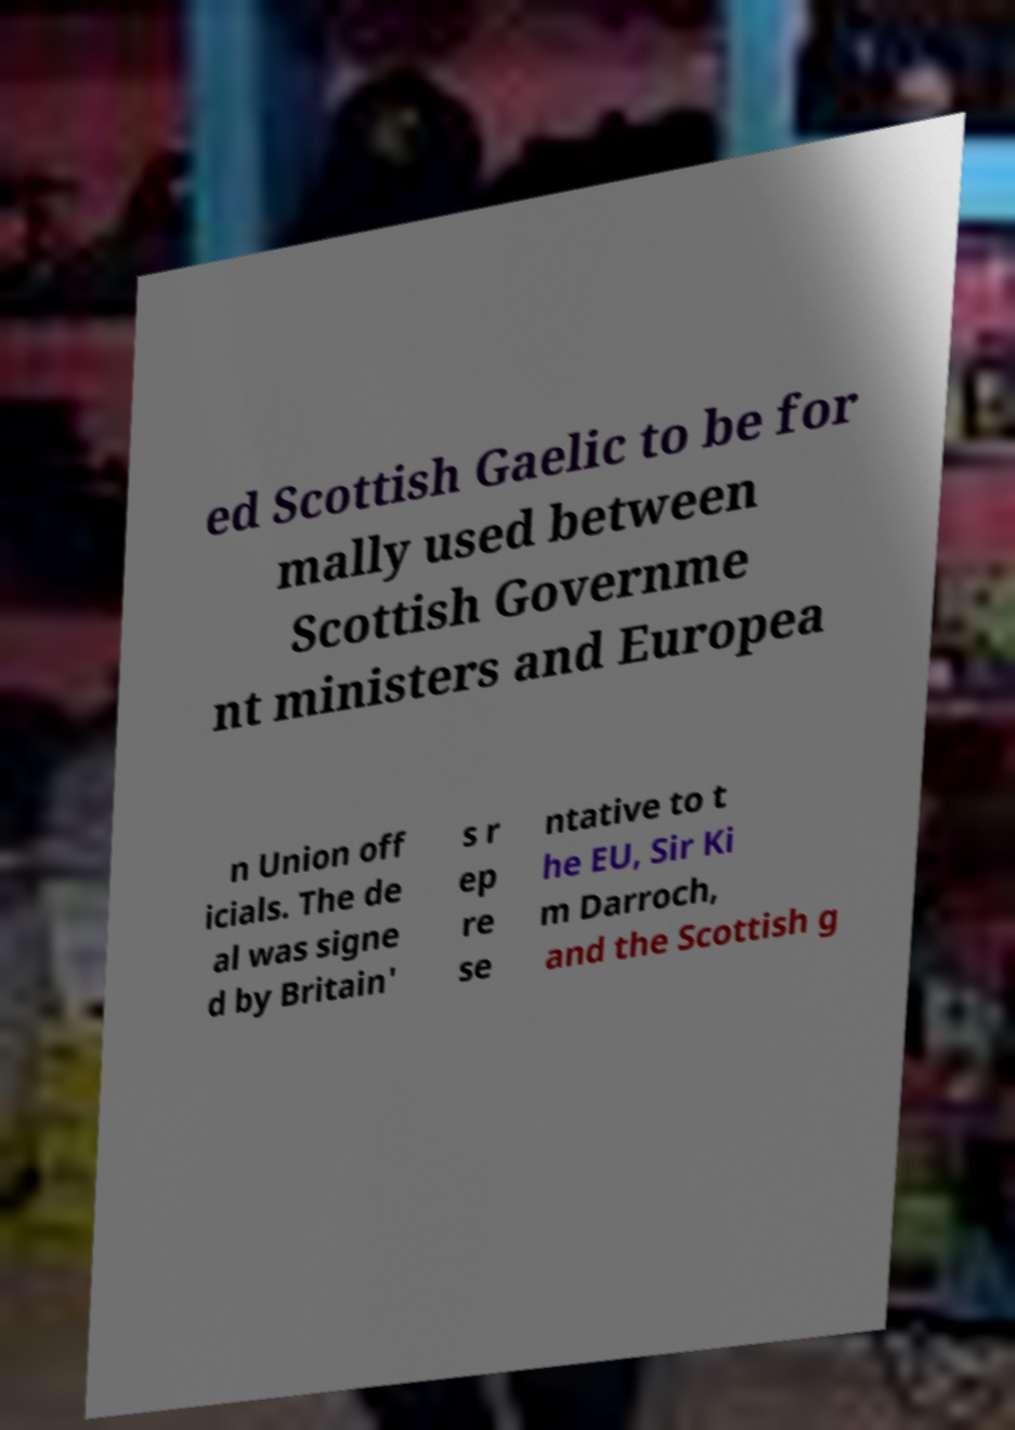I need the written content from this picture converted into text. Can you do that? ed Scottish Gaelic to be for mally used between Scottish Governme nt ministers and Europea n Union off icials. The de al was signe d by Britain' s r ep re se ntative to t he EU, Sir Ki m Darroch, and the Scottish g 